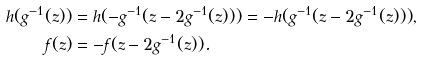<formula> <loc_0><loc_0><loc_500><loc_500>h ( g ^ { - 1 } ( z ) ) & = h ( - g ^ { - 1 } ( z - 2 g ^ { - 1 } ( z ) ) ) = - h ( g ^ { - 1 } ( z - 2 g ^ { - 1 } ( z ) ) ) , \\ f ( z ) & = - f ( z - 2 g ^ { - 1 } ( z ) ) .</formula> 